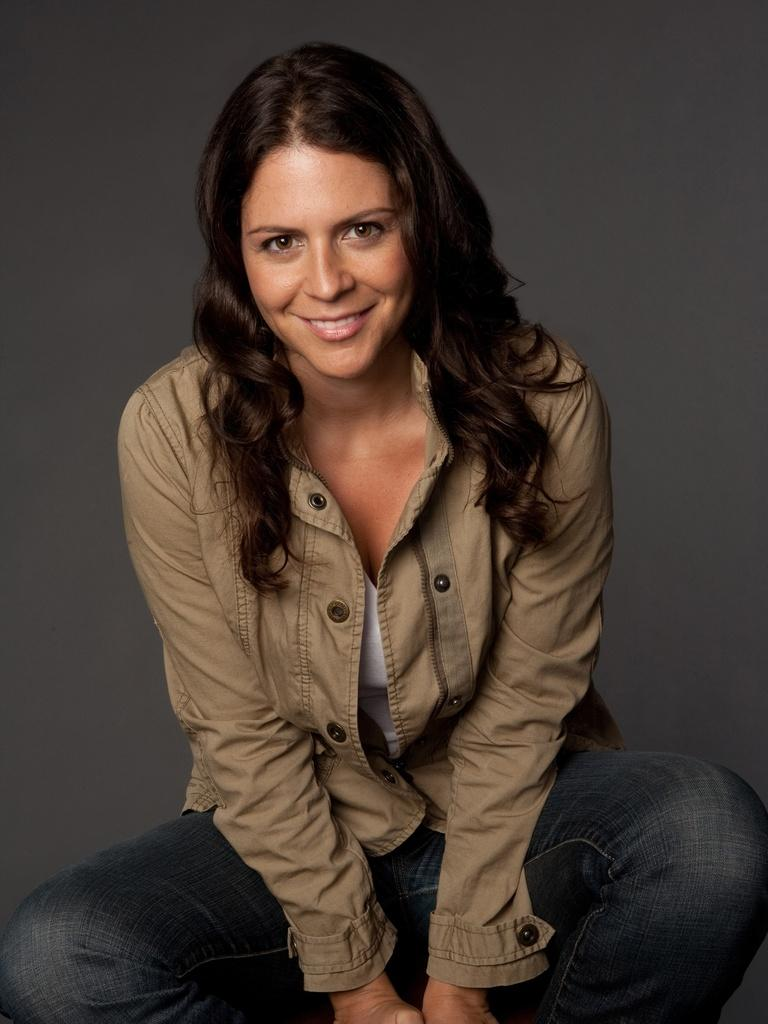What is the main subject of the image? There is a woman in the image. How many rabbits are playing the drum in the image? There are no rabbits or drums present in the image; it features a woman. What type of heart is visible in the image? There is no heart visible in the image; it features a woman. 